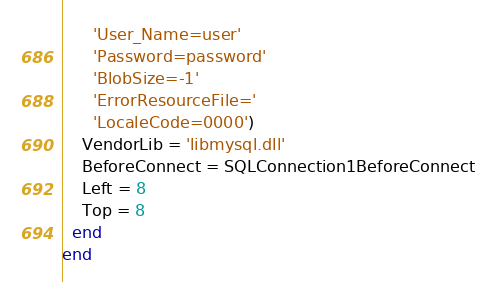<code> <loc_0><loc_0><loc_500><loc_500><_Pascal_>      'User_Name=user'
      'Password=password'
      'BlobSize=-1'
      'ErrorResourceFile='
      'LocaleCode=0000')
    VendorLib = 'libmysql.dll'
    BeforeConnect = SQLConnection1BeforeConnect
    Left = 8
    Top = 8
  end
end
</code> 